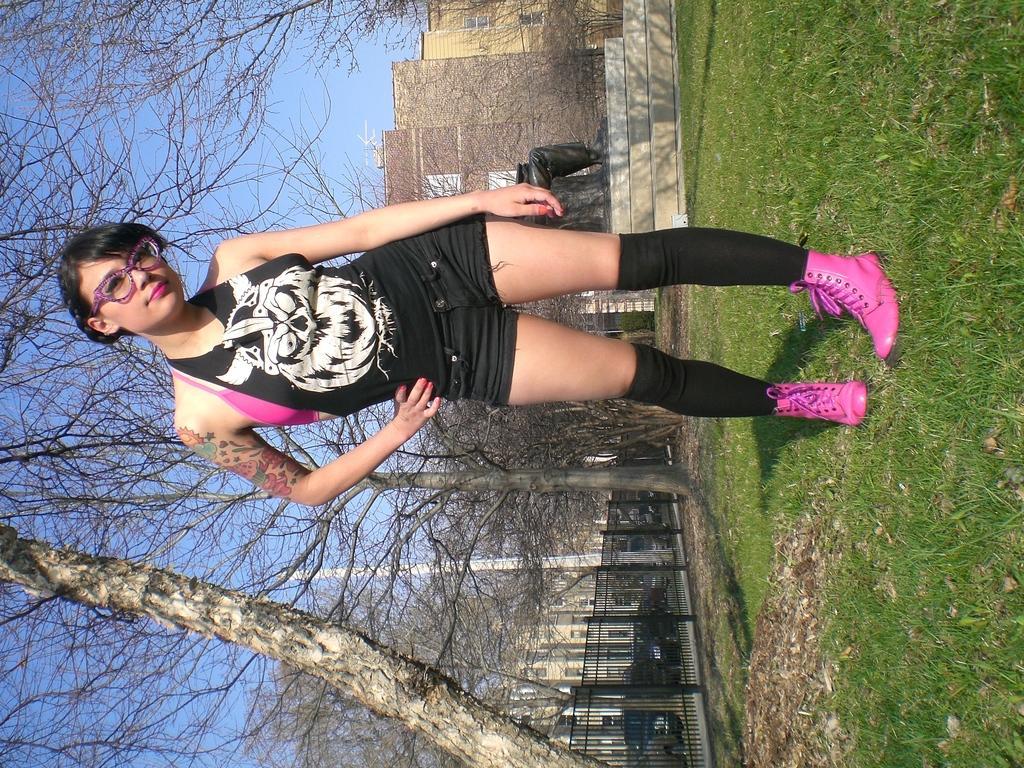In one or two sentences, can you explain what this image depicts? In the front of the image I can see a woman. Land is covered with grass. Background of the image there are trees, buildings, railings, vehicles, pole, statue and sky. 